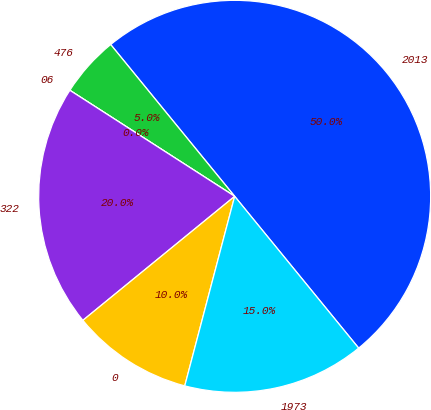<chart> <loc_0><loc_0><loc_500><loc_500><pie_chart><fcel>2013<fcel>476<fcel>06<fcel>322<fcel>0<fcel>1973<nl><fcel>50.0%<fcel>5.0%<fcel>0.0%<fcel>20.0%<fcel>10.0%<fcel>15.0%<nl></chart> 